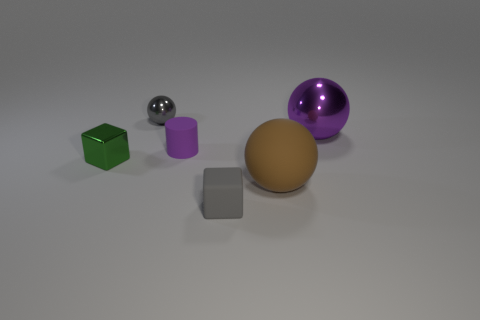Add 4 big matte balls. How many objects exist? 10 Subtract all cylinders. How many objects are left? 5 Subtract 0 gray cylinders. How many objects are left? 6 Subtract all large matte objects. Subtract all gray rubber things. How many objects are left? 4 Add 5 purple balls. How many purple balls are left? 6 Add 1 small green blocks. How many small green blocks exist? 2 